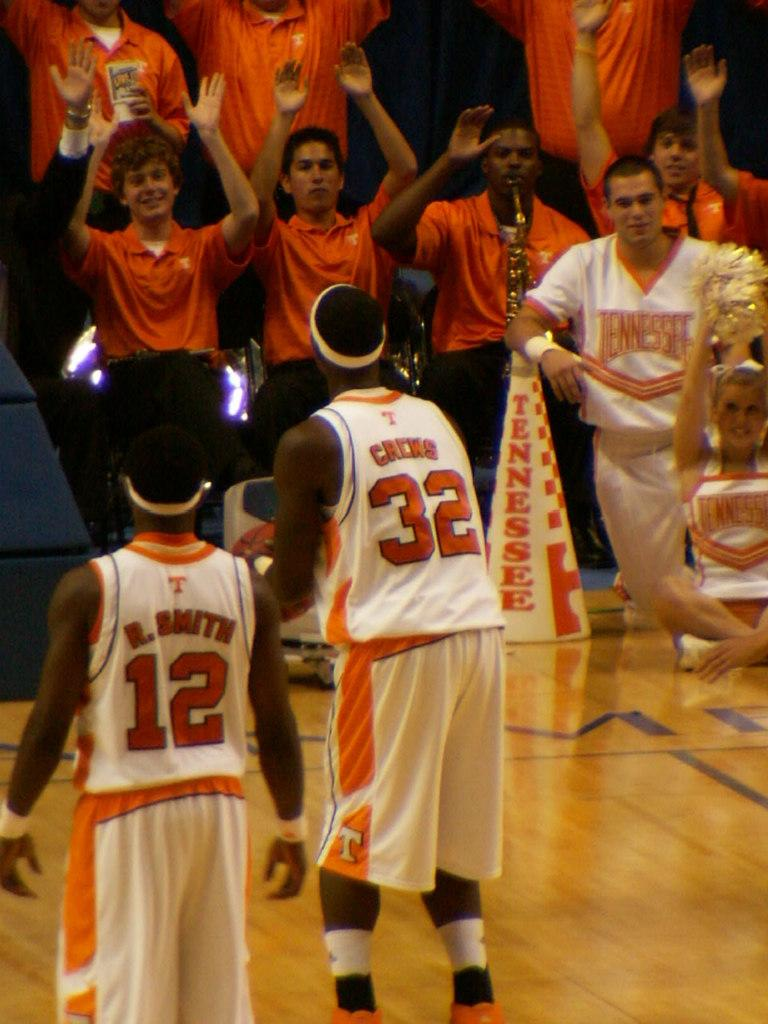<image>
Offer a succinct explanation of the picture presented. Two men with number 12 and 32 written on their orange and white jersey. 